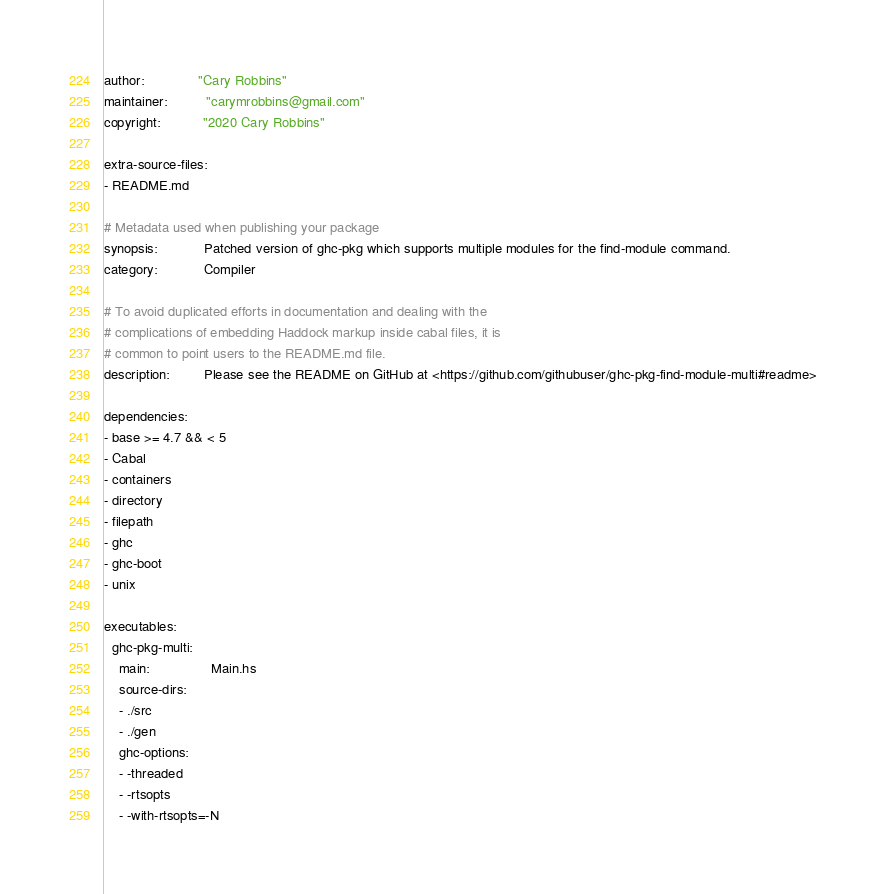<code> <loc_0><loc_0><loc_500><loc_500><_YAML_>author:              "Cary Robbins"
maintainer:          "carymrobbins@gmail.com"
copyright:           "2020 Cary Robbins"

extra-source-files:
- README.md

# Metadata used when publishing your package
synopsis:            Patched version of ghc-pkg which supports multiple modules for the find-module command.
category:            Compiler

# To avoid duplicated efforts in documentation and dealing with the
# complications of embedding Haddock markup inside cabal files, it is
# common to point users to the README.md file.
description:         Please see the README on GitHub at <https://github.com/githubuser/ghc-pkg-find-module-multi#readme>

dependencies:
- base >= 4.7 && < 5
- Cabal
- containers
- directory
- filepath
- ghc
- ghc-boot
- unix

executables:
  ghc-pkg-multi:
    main:                Main.hs
    source-dirs:
    - ./src
    - ./gen
    ghc-options:
    - -threaded
    - -rtsopts
    - -with-rtsopts=-N
</code> 